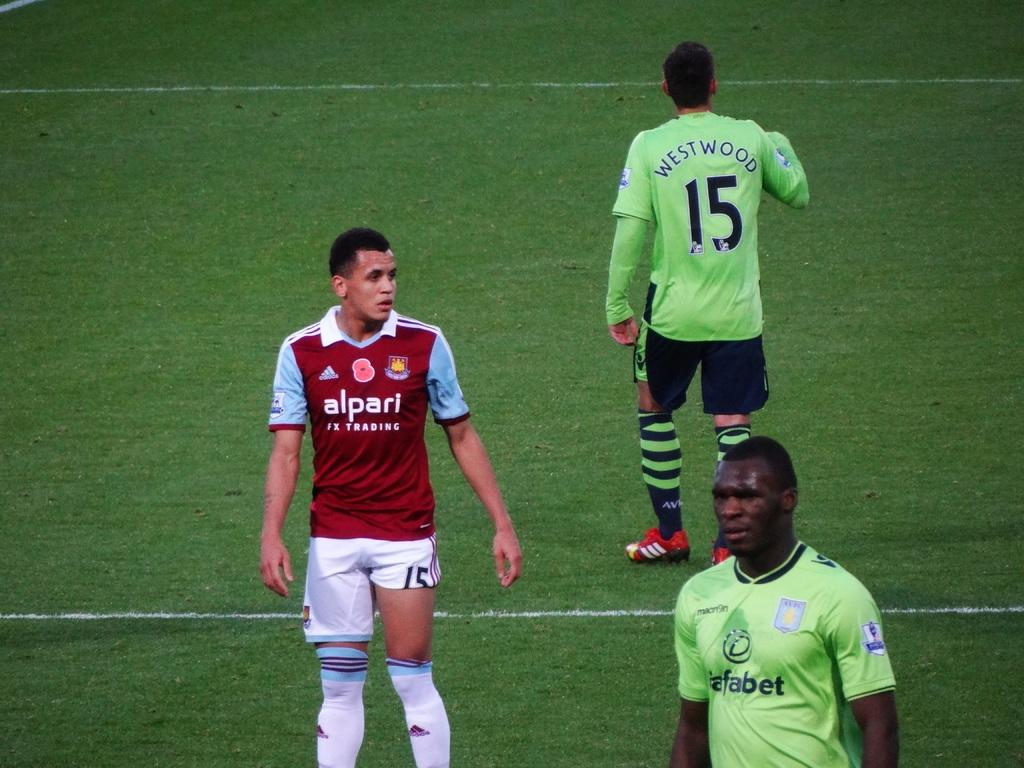<image>
Present a compact description of the photo's key features. An alpari male athlete standing with 2 other men in green uniforms, one named Westwood. 